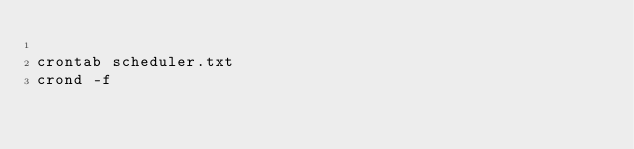<code> <loc_0><loc_0><loc_500><loc_500><_Bash_>
crontab scheduler.txt
crond -f


</code> 